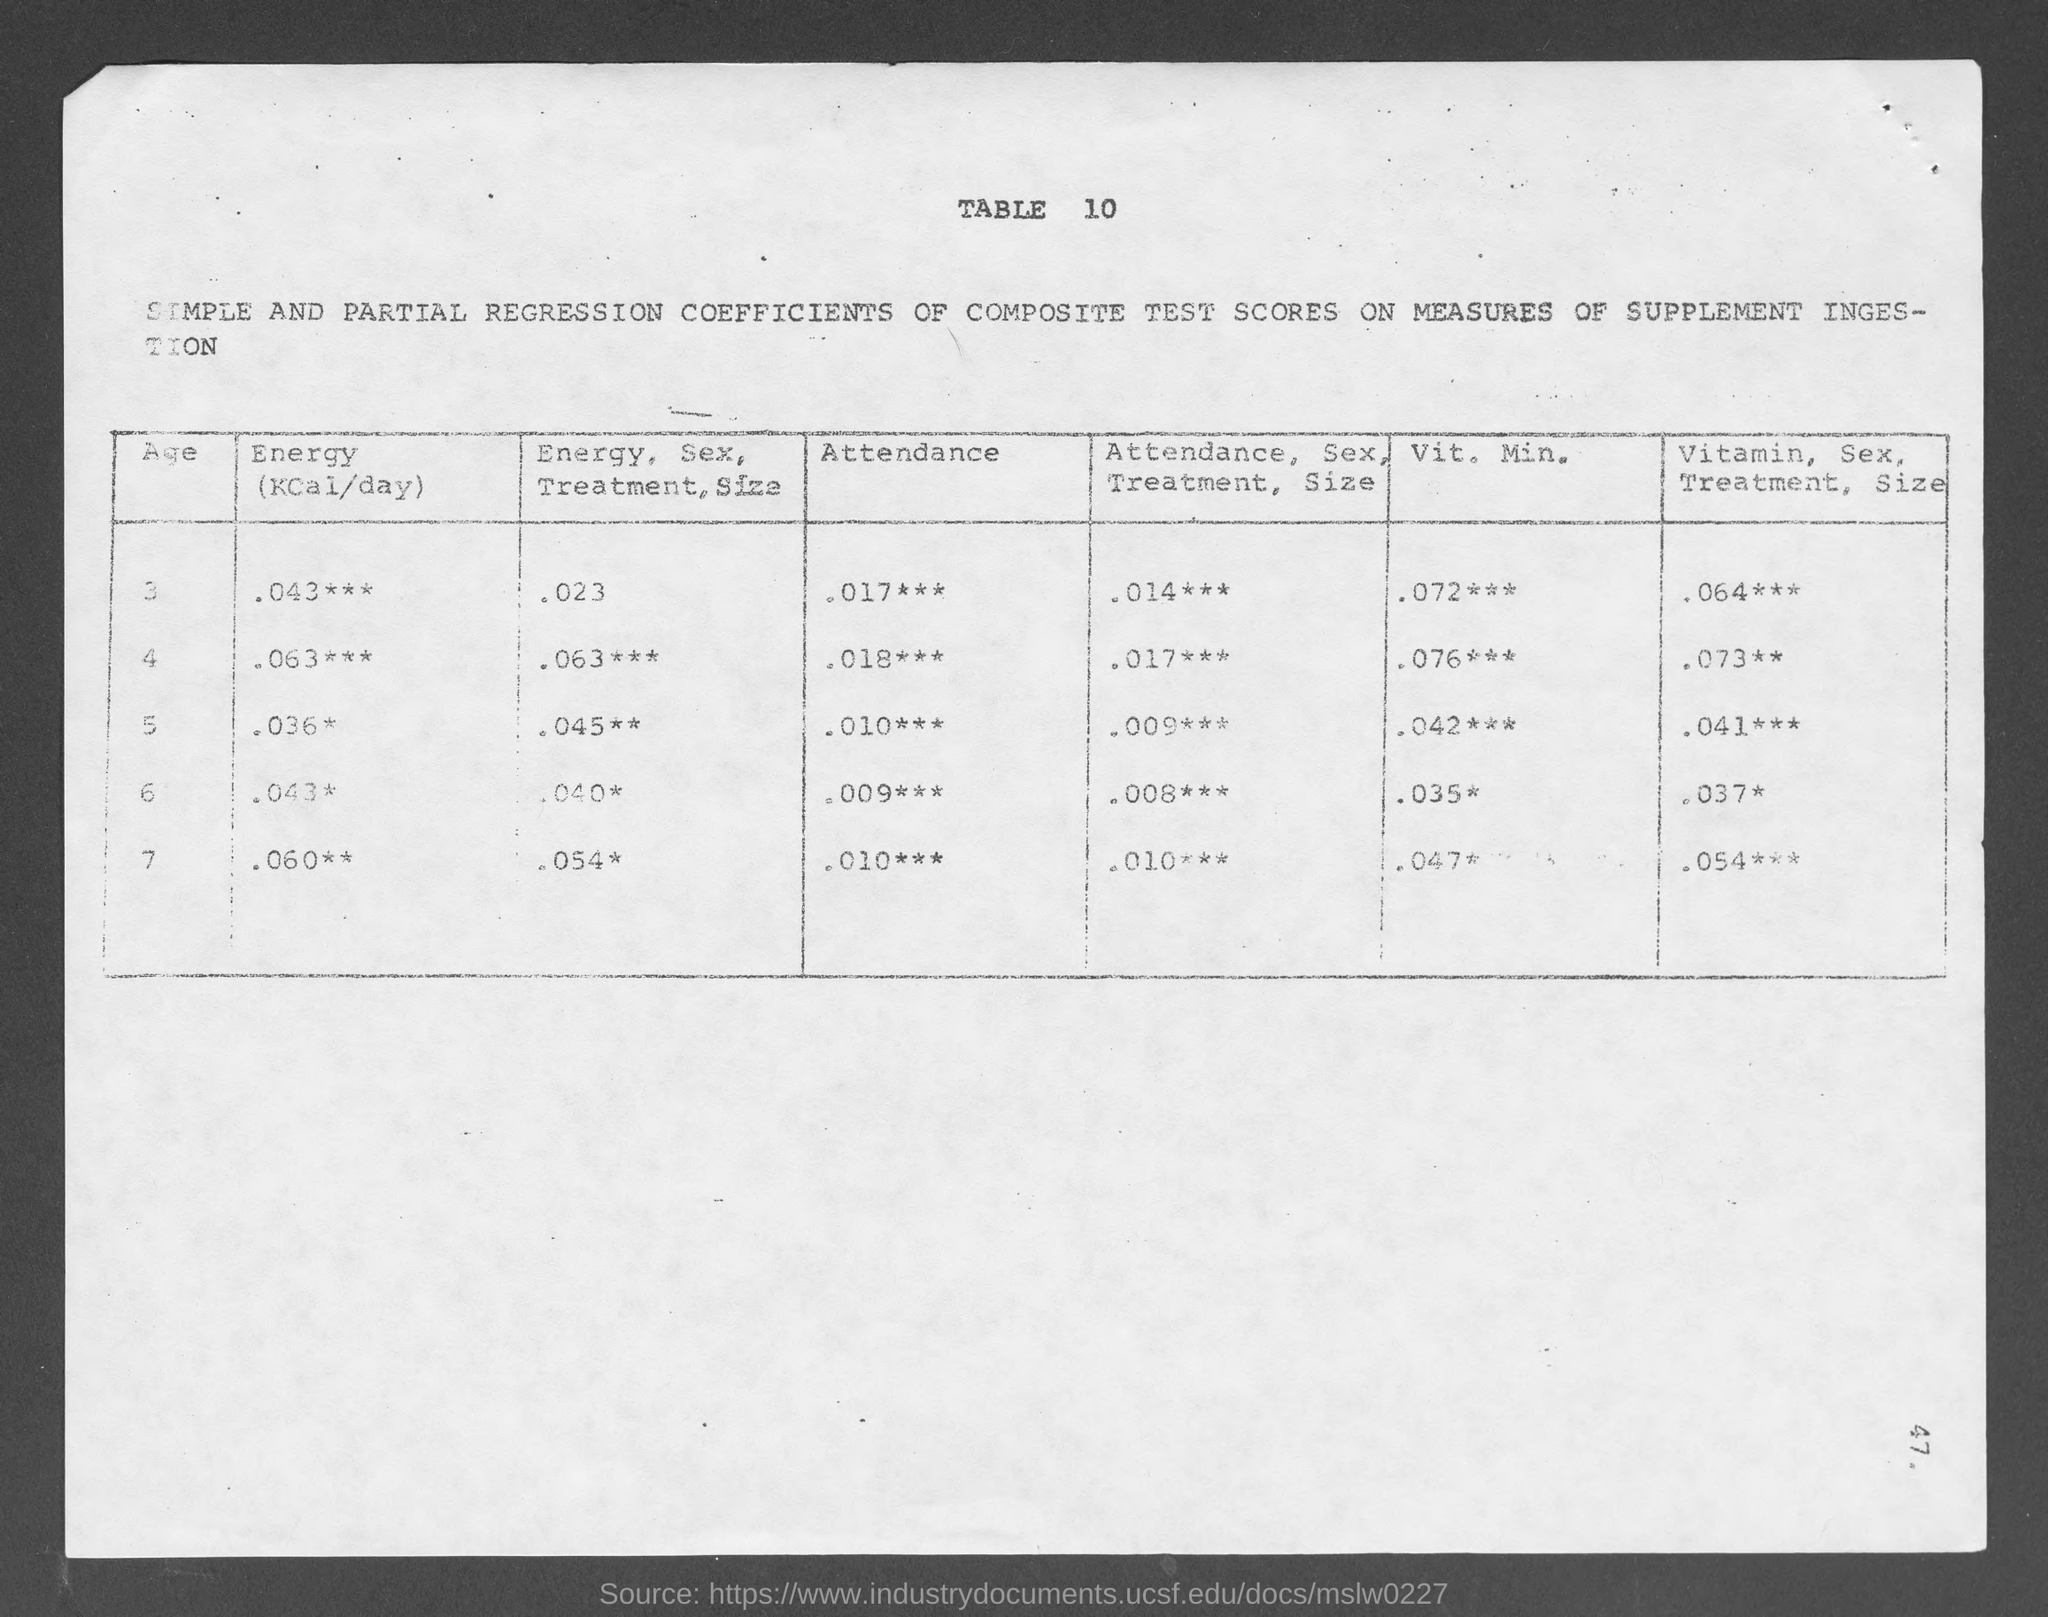What is the table no.?
Keep it short and to the point. 10. What is the amount of energy (kcal/day) for age 3?
Provide a succinct answer. .043. What is the amount of energy (kcal/day) for age 4?
Provide a short and direct response. 0.63. What is the amount of energy (kcal/day) for age 5?
Provide a short and direct response. 0.36. What is the amount of energy (kcal/day) for age 6?
Give a very brief answer. .043. 